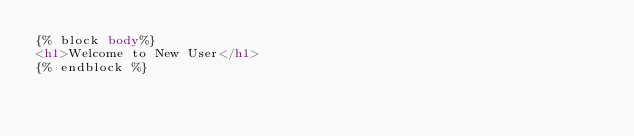Convert code to text. <code><loc_0><loc_0><loc_500><loc_500><_HTML_>{% block body%}
<h1>Welcome to New User</h1>
{% endblock %}
</code> 